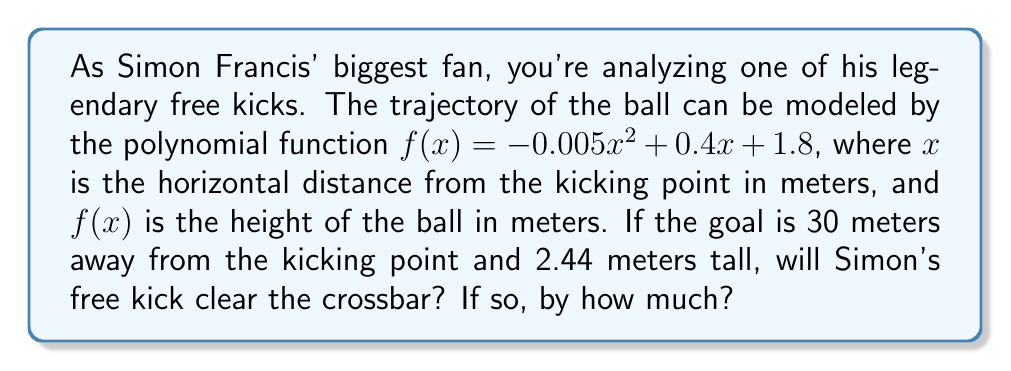Provide a solution to this math problem. To solve this problem, we need to follow these steps:

1) First, we need to find the height of the ball when it reaches the goal line. This means we need to calculate $f(30)$, since the goal is 30 meters away.

   $f(30) = -0.005(30)^2 + 0.4(30) + 1.8$
   $= -0.005(900) + 12 + 1.8$
   $= -4.5 + 12 + 1.8$
   $= 9.3$ meters

2) Now we know that when the ball reaches the goal line, it will be at a height of 9.3 meters.

3) The goal is 2.44 meters tall. To find out if the ball clears the crossbar and by how much, we need to subtract the height of the goal from the height of the ball:

   $9.3 - 2.44 = 6.86$ meters

4) Since this result is positive, we know that the ball does indeed clear the crossbar.

Therefore, Simon's free kick will clear the crossbar by 6.86 meters.
Answer: Yes, Simon's free kick will clear the crossbar by 6.86 meters. 